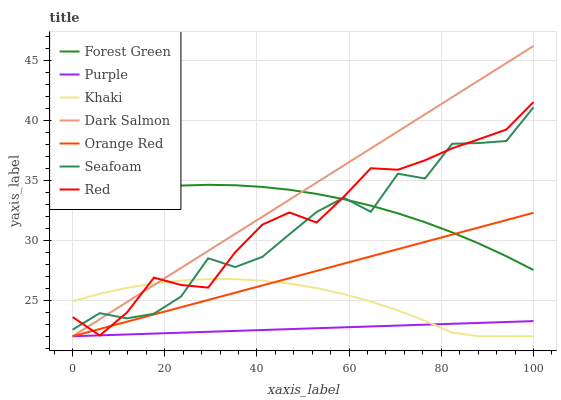Does Seafoam have the minimum area under the curve?
Answer yes or no. No. Does Seafoam have the maximum area under the curve?
Answer yes or no. No. Is Seafoam the smoothest?
Answer yes or no. No. Is Purple the roughest?
Answer yes or no. No. Does Seafoam have the lowest value?
Answer yes or no. No. Does Seafoam have the highest value?
Answer yes or no. No. Is Purple less than Seafoam?
Answer yes or no. Yes. Is Seafoam greater than Orange Red?
Answer yes or no. Yes. Does Purple intersect Seafoam?
Answer yes or no. No. 